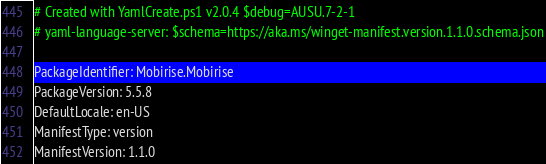<code> <loc_0><loc_0><loc_500><loc_500><_YAML_># Created with YamlCreate.ps1 v2.0.4 $debug=AUSU.7-2-1
# yaml-language-server: $schema=https://aka.ms/winget-manifest.version.1.1.0.schema.json

PackageIdentifier: Mobirise.Mobirise
PackageVersion: 5.5.8
DefaultLocale: en-US
ManifestType: version
ManifestVersion: 1.1.0
</code> 